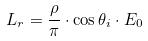<formula> <loc_0><loc_0><loc_500><loc_500>L _ { r } = \frac { \rho } { \pi } \cdot \cos \theta _ { i } \cdot E _ { 0 }</formula> 